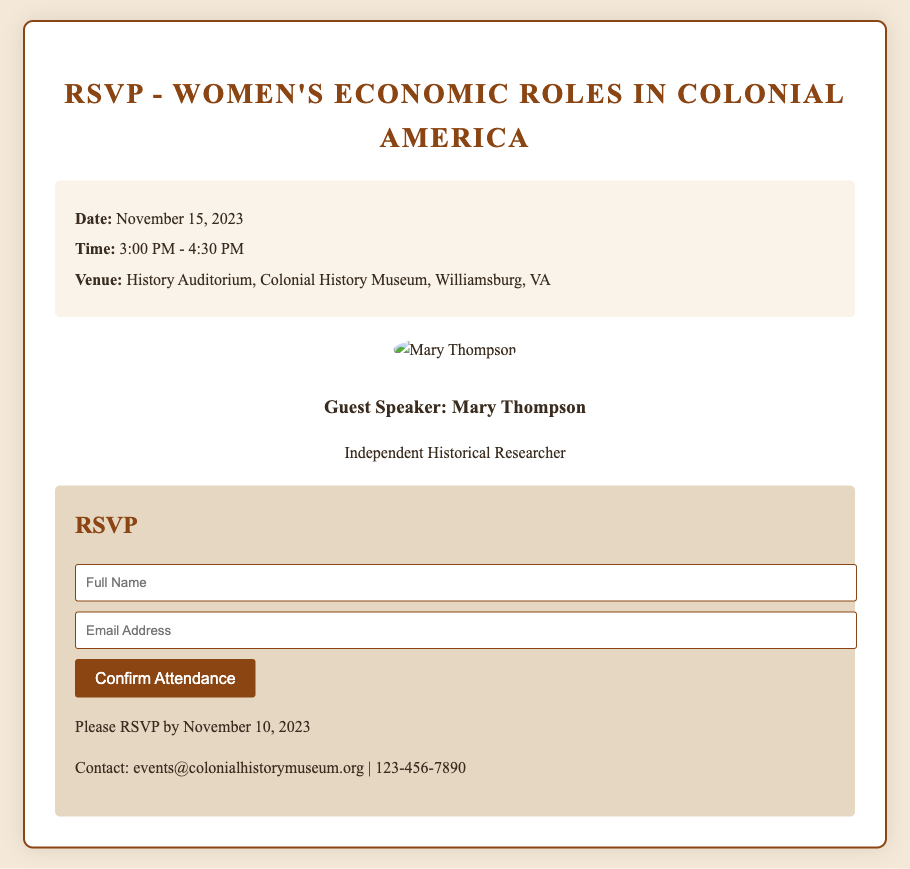What is the date of the lecture? The date of the lecture is explicitly mentioned in the details section of the document.
Answer: November 15, 2023 What time does the lecture start? The starting time is provided in the details section of the RSVP card.
Answer: 3:00 PM Who is the guest speaker? The name of the guest speaker is presented in the speaker section of the document.
Answer: Mary Thompson What is the venue for the lecture? The venue is listed in the details section as the location of the event.
Answer: History Auditorium, Colonial History Museum, Williamsburg, VA When is the RSVP deadline? The RSVP deadline is specified in the RSVP section of the document.
Answer: November 10, 2023 What type of researcher is Mary Thompson? The document states the profession of the guest speaker in the speaker section.
Answer: Independent Historical Researcher How long is the lecture scheduled to last? The duration is inferred from the time stated in the details section: from start to end time.
Answer: 1 hour 30 minutes What is the contact email for the event? The contact email is provided at the bottom of the RSVP form.
Answer: events@colonialhistorymuseum.org What is the background color of the card? The background color can be inferred from the general layout and style information provided in the document.
Answer: #f4e9d8 